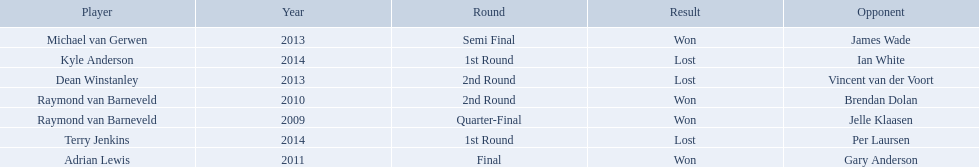Who were all the players? Raymond van Barneveld, Raymond van Barneveld, Adrian Lewis, Dean Winstanley, Michael van Gerwen, Terry Jenkins, Kyle Anderson. Which of these played in 2014? Terry Jenkins, Kyle Anderson. Who were their opponents? Per Laursen, Ian White. Which of these beat terry jenkins? Per Laursen. 